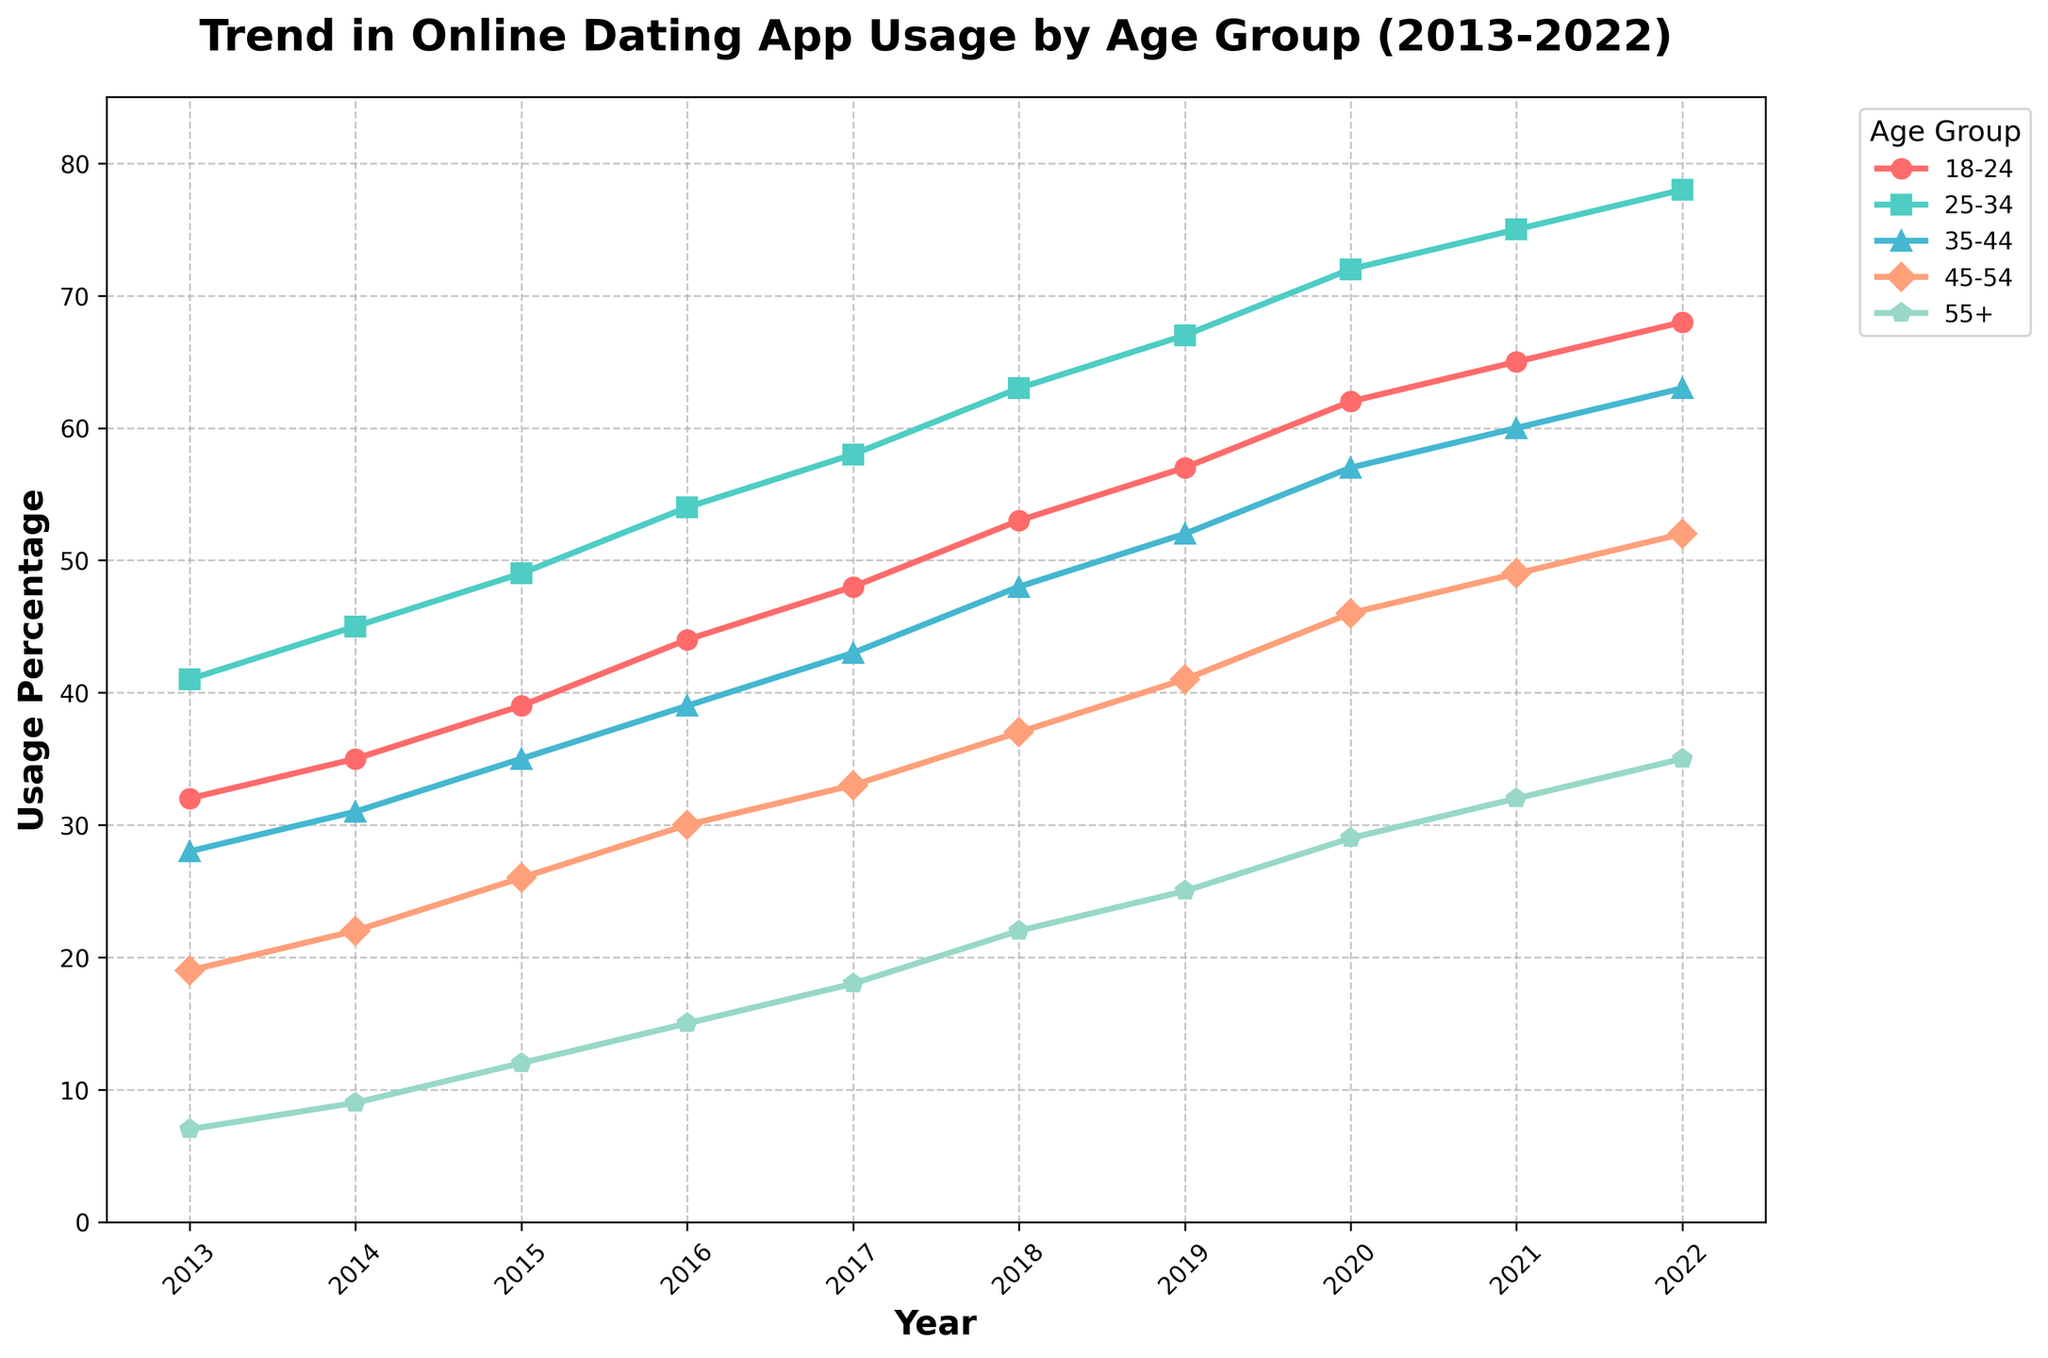What's the trend in online dating app usage for the 18-24 age group from 2013 to 2022? The usage percentage for the 18-24 age group consistently increases from 32% in 2013 to 68% in 2022.
Answer: Consistent increase Which age group had the highest usage percentage in 2020? In 2020, the 25-34 age group had the highest usage percentage at 72%.
Answer: 25-34 age group Did the 35-44 age group usage ever surpass the 25-34 age group usage between 2013 and 2022? No, the 35-44 age group usage remained consistently lower than the 25-34 age group usage throughout the given period.
Answer: No What is the difference in usage percentage between the 18-24 and 55+ age groups in 2022? In 2022, the 18-24 age group had a usage percentage of 68%, and the 55+ age group had 35%. The difference is 68% - 35% = 33%.
Answer: 33% Which age group shows the most significant increase in usage percentage from 2013 to 2022? To determine the most significant increase, calculate the difference between 2022 and 2013 for each age group: 18-24: 68%-32%=36%, 25-34: 78%-41%=37%, 35-44: 63%-28%=35%, 45-54: 52%-19%=33%, 55+: 35%-7%=28%. The 25-34 age group shows the most significant increase at 37%.
Answer: 25-34 age group In which year did the 45-54 age group surpass a usage percentage of 40%? The 45-54 age group surpassed 40% usage in 2019, where it reached 41%.
Answer: 2019 How does the trend for the 55+ age group compare visually with the trend for the 18-24 age group between 2013 and 2022? Visually, both age groups show an increasing trend over the years. However, the slope for the 18-24 age group is steeper, indicating a faster increase compared to the 55+ age group.
Answer: Faster increase for 18-24 Which two age groups have the closest usage percentages in 2015? In 2015, the usage percentages are: 18-24 at 39%, 25-34 at 49%, 35-44 at 35%, 45-54 at 26%, and 55+ at 12%. The 35-44 and 25-34 age groups have the closest percentages: 35% and 39%, respectively.
Answer: 35-44 and 18-24 age groups What is the overall trend in online dating app usage across all age groups from 2013 to 2022? The overall trend indicates an increase in online dating app usage across all age groups from 2013 to 2022.
Answer: Increasing trend 